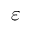Convert formula to latex. <formula><loc_0><loc_0><loc_500><loc_500>\varepsilon</formula> 